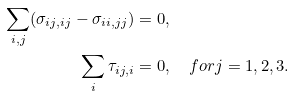<formula> <loc_0><loc_0><loc_500><loc_500>\sum _ { i , j } ( \sigma _ { i j , i j } - \sigma _ { i i , j j } ) & = 0 , \\ \sum _ { i } \tau _ { i j , i } & = 0 , \quad f o r j = 1 , 2 , 3 .</formula> 